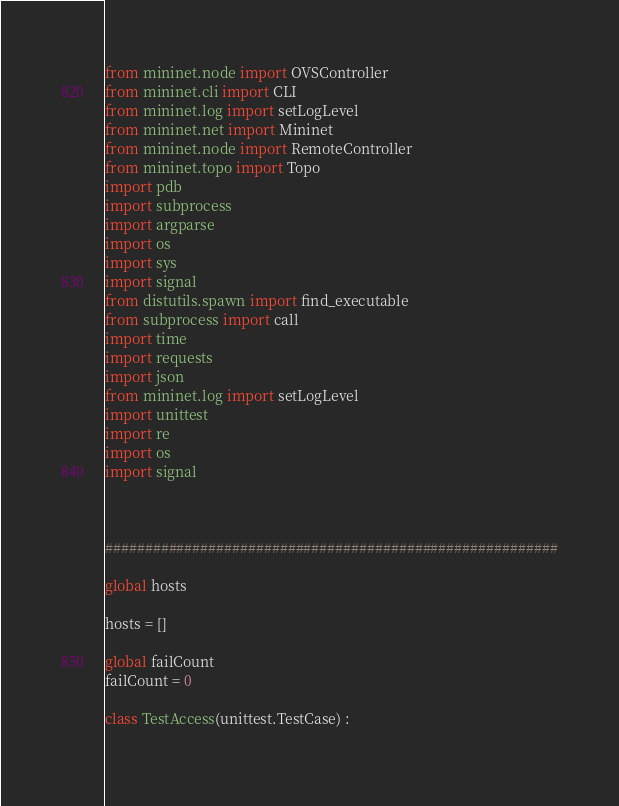Convert code to text. <code><loc_0><loc_0><loc_500><loc_500><_Python_>
from mininet.node import OVSController
from mininet.cli import CLI
from mininet.log import setLogLevel
from mininet.net import Mininet
from mininet.node import RemoteController
from mininet.topo import Topo
import pdb
import subprocess
import argparse
import os
import sys
import signal
from distutils.spawn import find_executable
from subprocess import call
import time
import requests
import json
from mininet.log import setLogLevel 
import unittest
import re
import os
import signal



#########################################################

global hosts

hosts = []

global failCount
failCount = 0

class TestAccess(unittest.TestCase) :
    </code> 